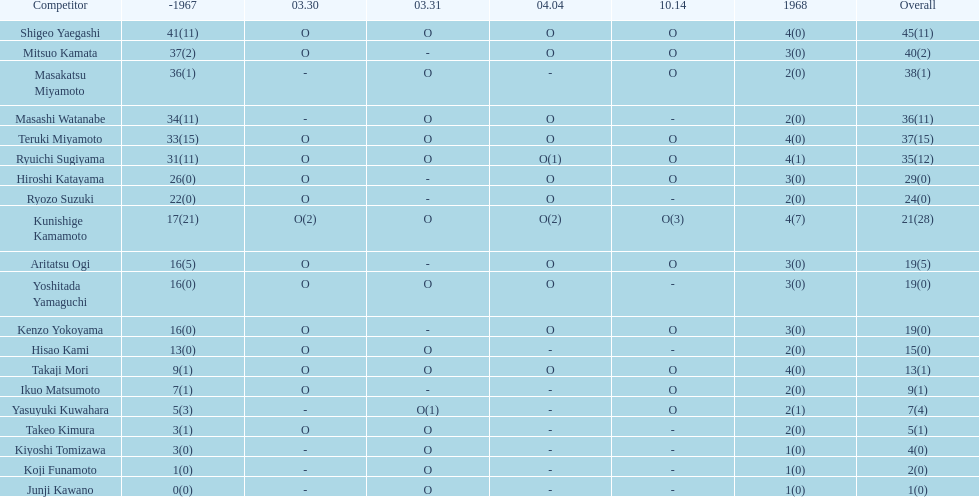Total appearances by masakatsu miyamoto? 38. 